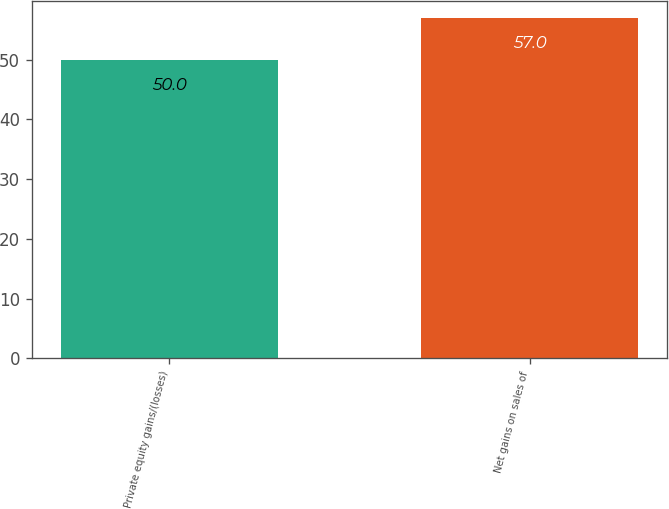Convert chart to OTSL. <chart><loc_0><loc_0><loc_500><loc_500><bar_chart><fcel>Private equity gains/(losses)<fcel>Net gains on sales of<nl><fcel>50<fcel>57<nl></chart> 